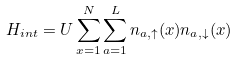<formula> <loc_0><loc_0><loc_500><loc_500>H _ { i n t } = U \sum _ { x = 1 } ^ { N } \sum _ { a = 1 } ^ { L } n _ { a , \uparrow } ( x ) n _ { a , \downarrow } ( x )</formula> 